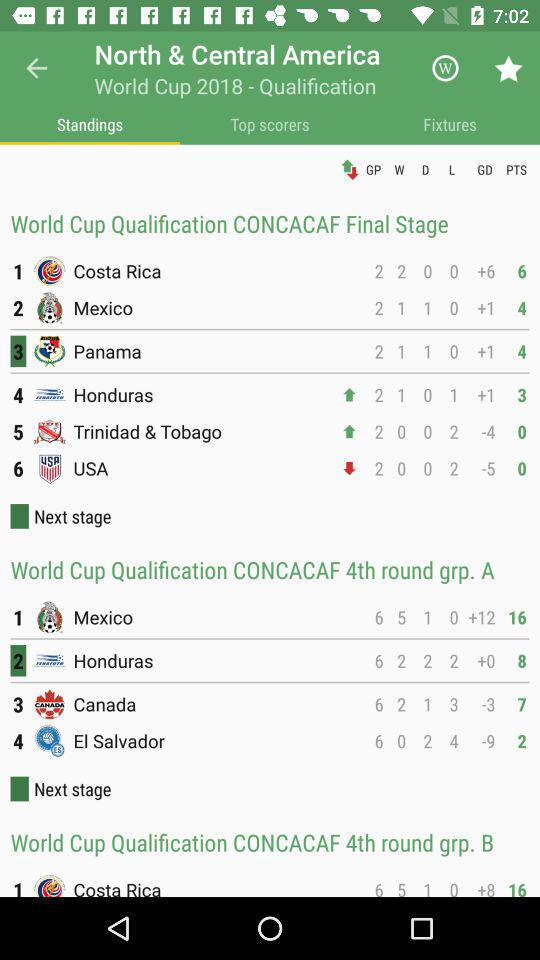How many matches did the USA lose in "CONCACAF"? The USA lost 2 matches in "CONCACAF". 